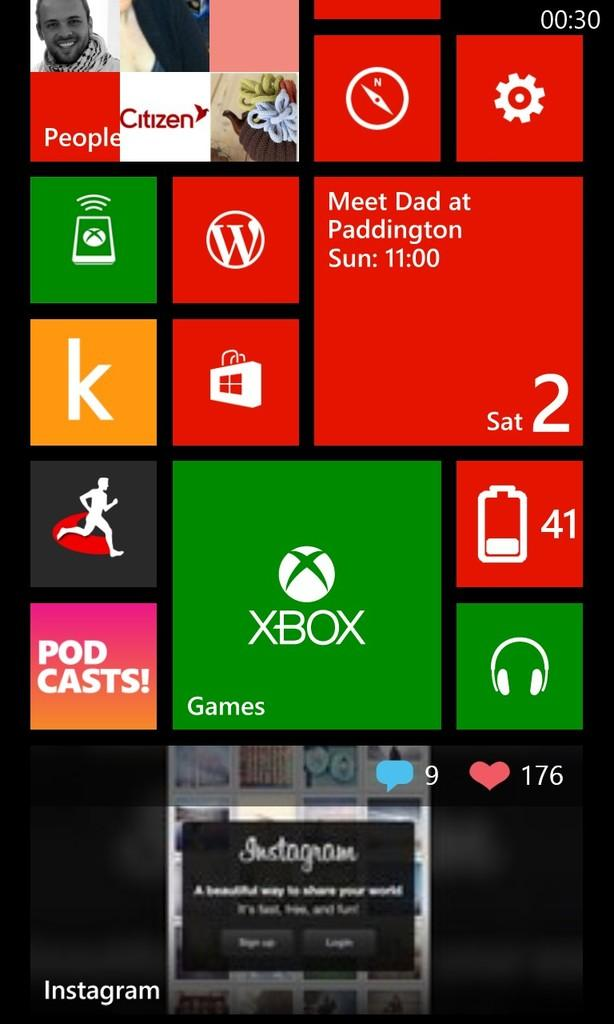<image>
Share a concise interpretation of the image provided. A screen with an x box logo, Instagram, A note that says meet dad a podcast and a music logo, games and battery percentage 